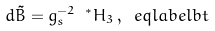<formula> <loc_0><loc_0><loc_500><loc_500>d \tilde { B } = g _ { s } ^ { - 2 } \ ^ { * } H _ { 3 } \, , \ e q l a b e l { b t }</formula> 